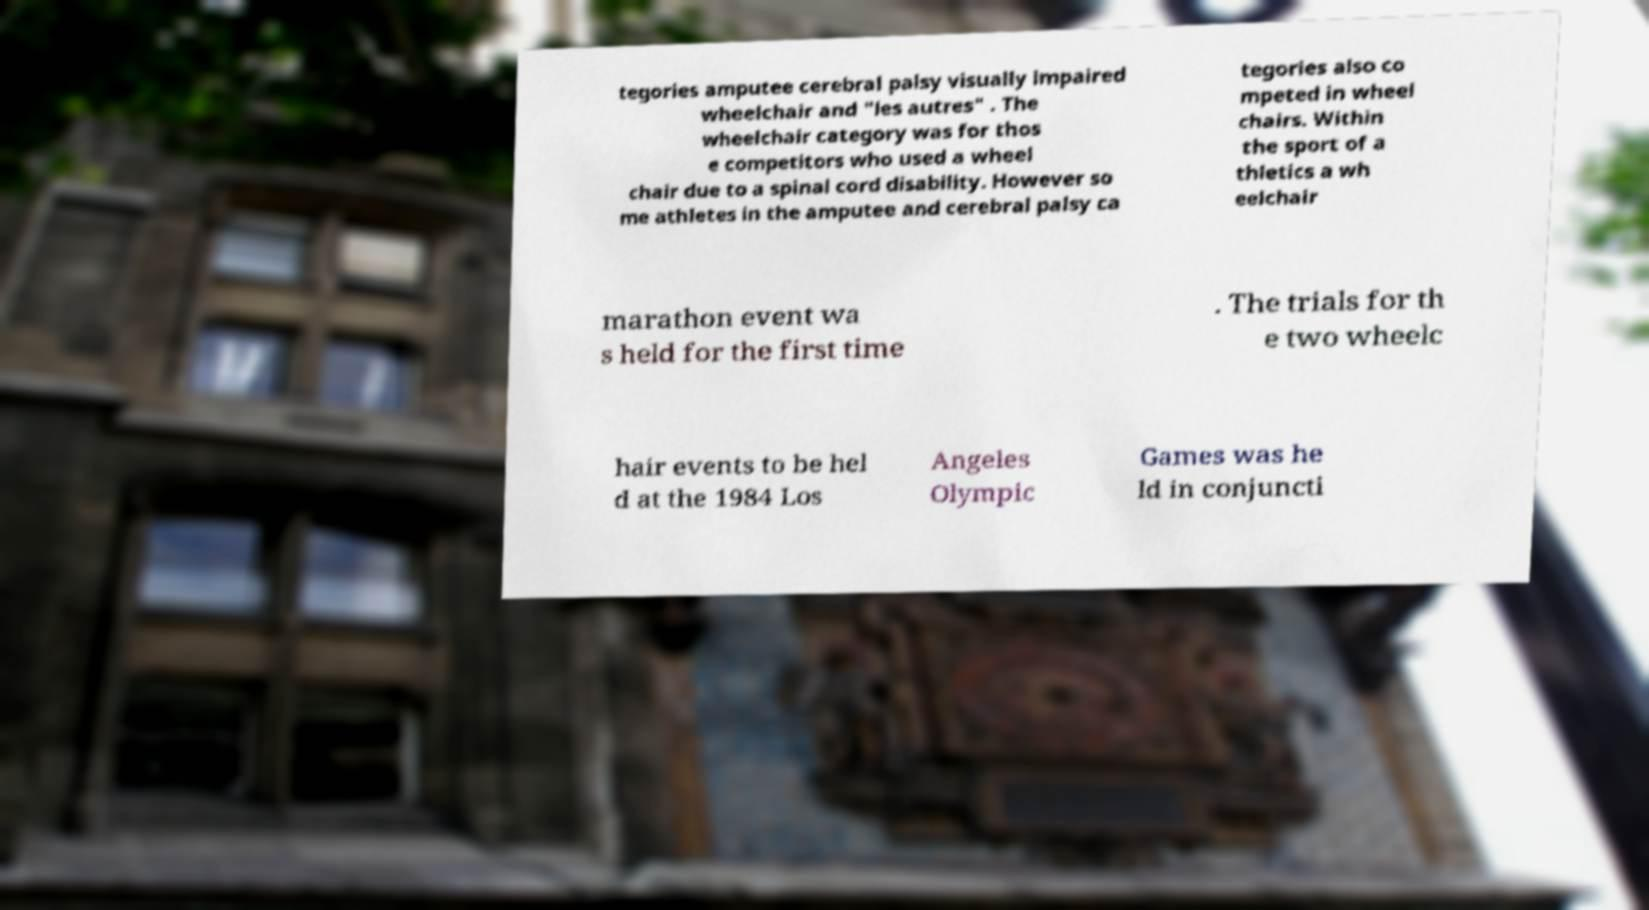There's text embedded in this image that I need extracted. Can you transcribe it verbatim? tegories amputee cerebral palsy visually impaired wheelchair and "les autres" . The wheelchair category was for thos e competitors who used a wheel chair due to a spinal cord disability. However so me athletes in the amputee and cerebral palsy ca tegories also co mpeted in wheel chairs. Within the sport of a thletics a wh eelchair marathon event wa s held for the first time . The trials for th e two wheelc hair events to be hel d at the 1984 Los Angeles Olympic Games was he ld in conjuncti 